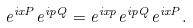<formula> <loc_0><loc_0><loc_500><loc_500>e ^ { i x P } e ^ { i p Q } = e ^ { i x p } e ^ { i p Q } e ^ { i x P } .</formula> 